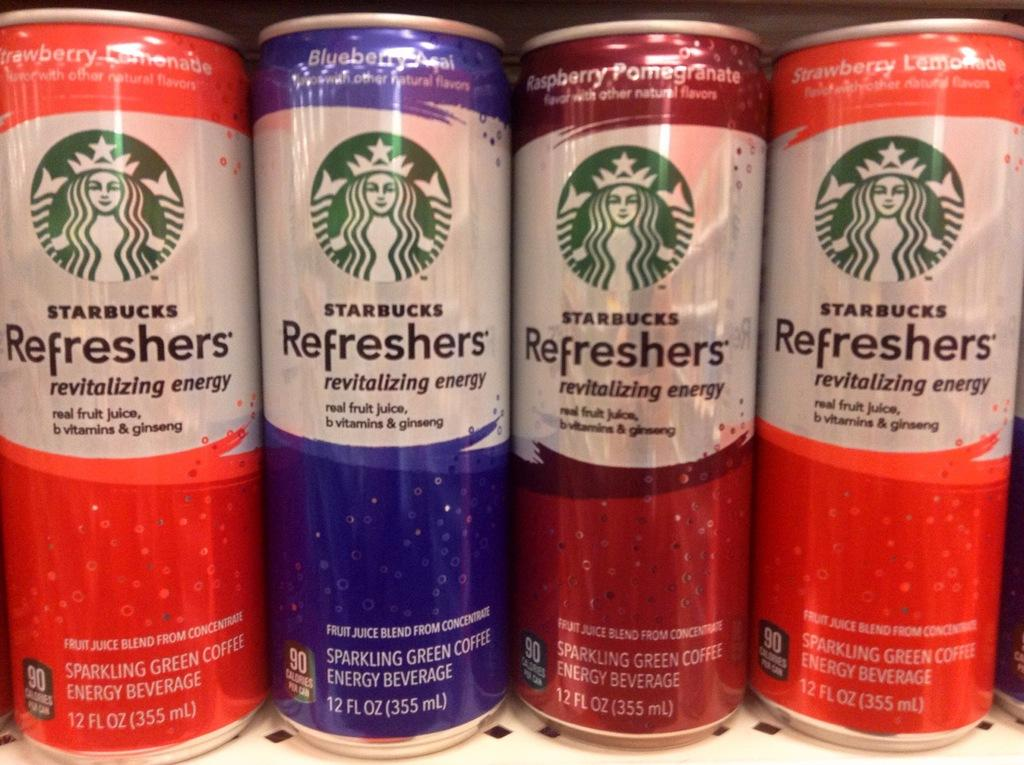Provide a one-sentence caption for the provided image. Four cans of Starbucks Refreshers are lined up on a shelf. 